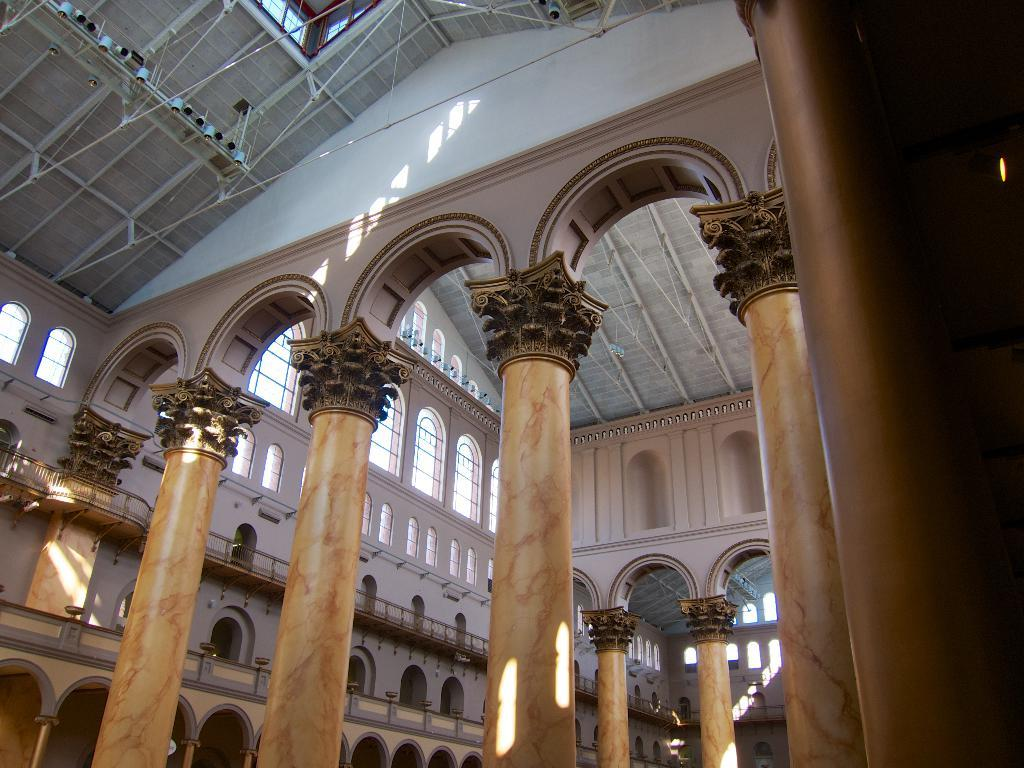What type of structure is shown in the image? The image shows an inner view of a building. What architectural features can be seen in the building? There are pillars and windows in the building. What safety feature is present in the building? The building has a railing. What is the uppermost part of the building? The building has a roof. What type of lighting is present in the building? There are ceiling lights in the building. Can you see any fairies flying around in the building? There are no fairies present in the image; it shows an inner view of a building with architectural features and lighting. Is there a goat grazing on the roof of the building? There is no goat present on the roof of the building in the image. 